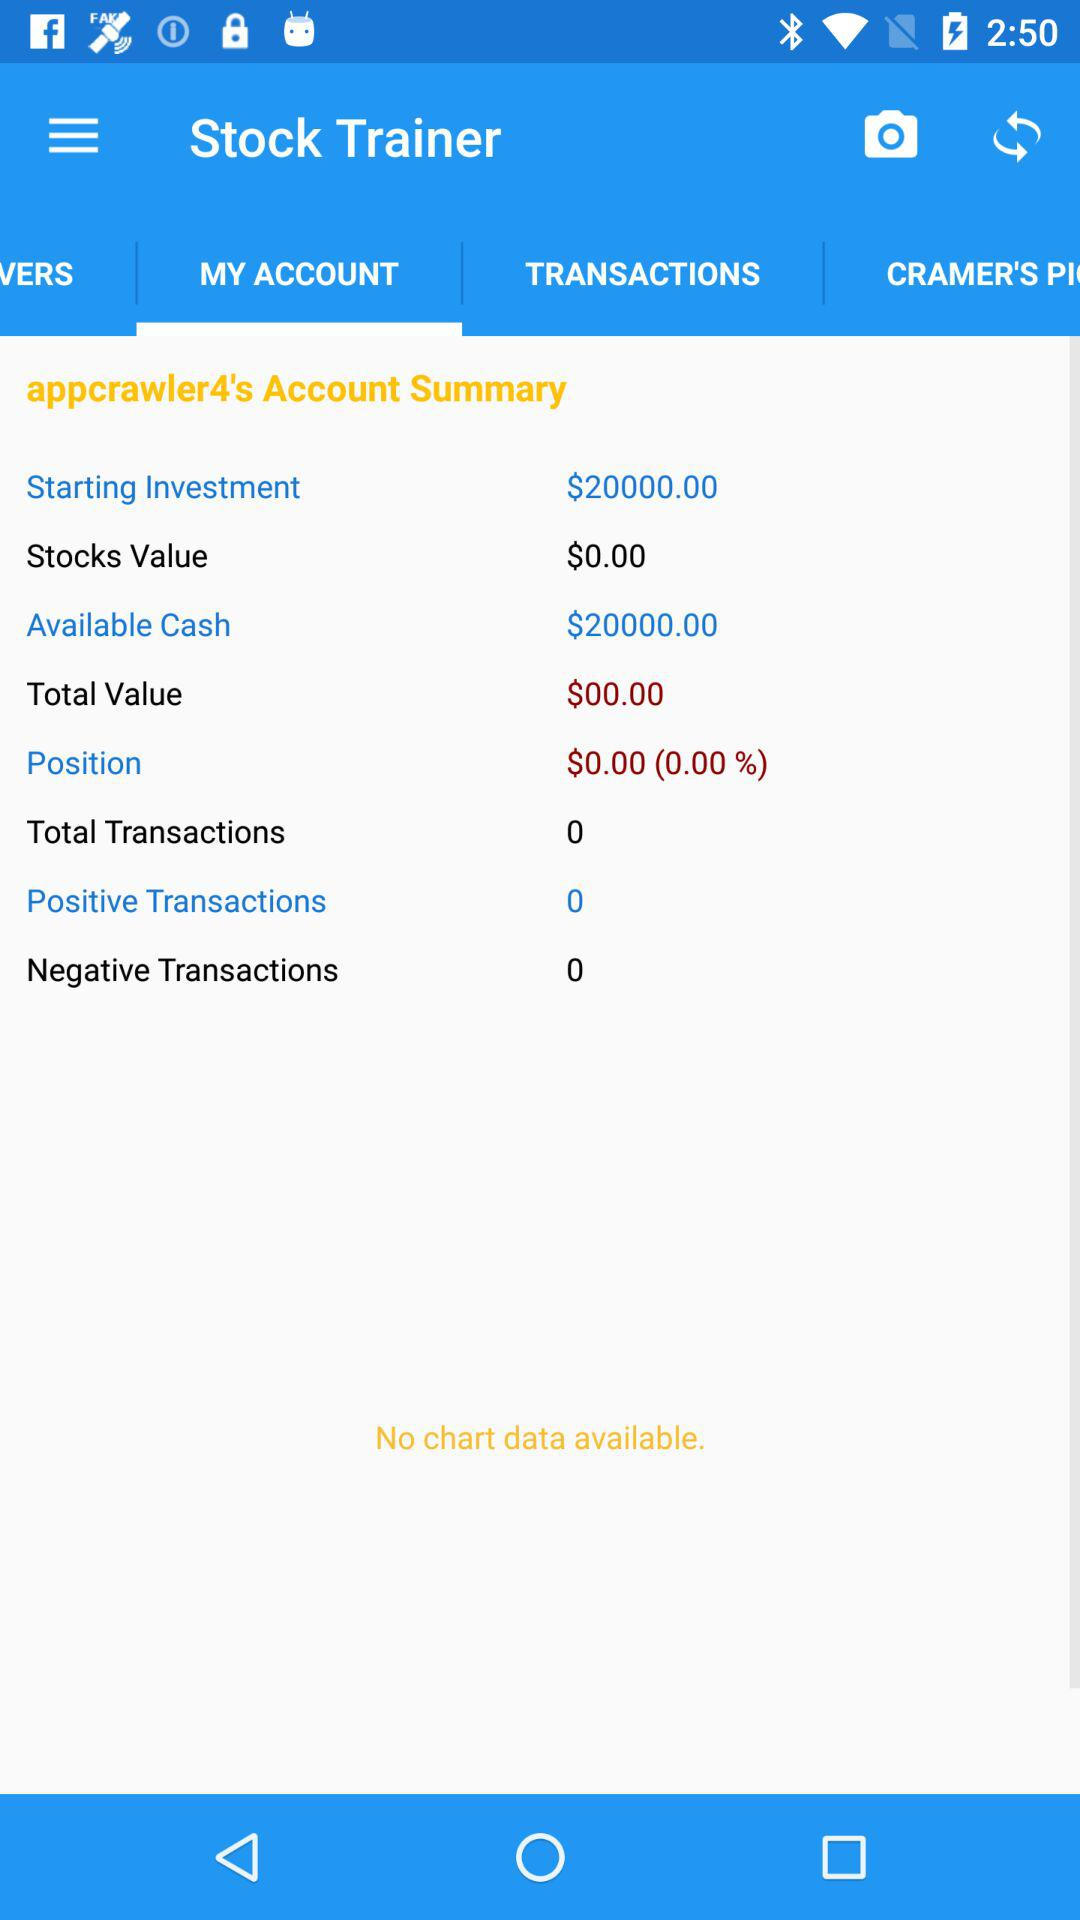How many positive transactions are there?
Answer the question using a single word or phrase. 0 